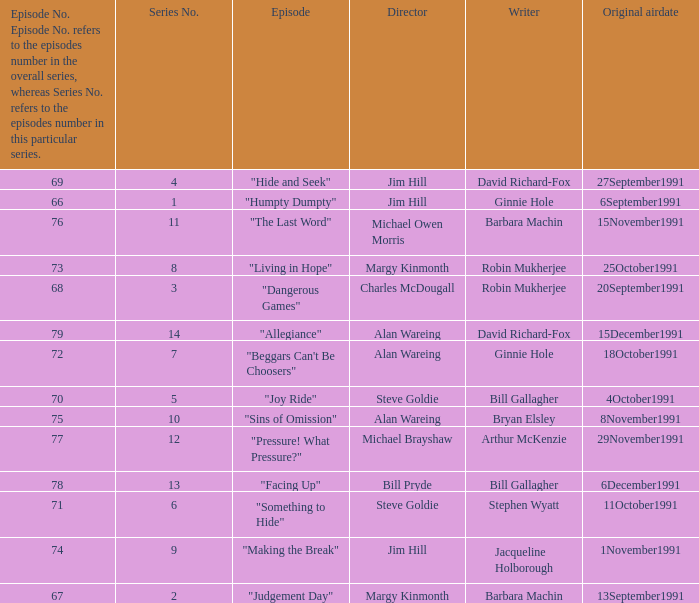Name the least series number for episode number being 78 13.0. 